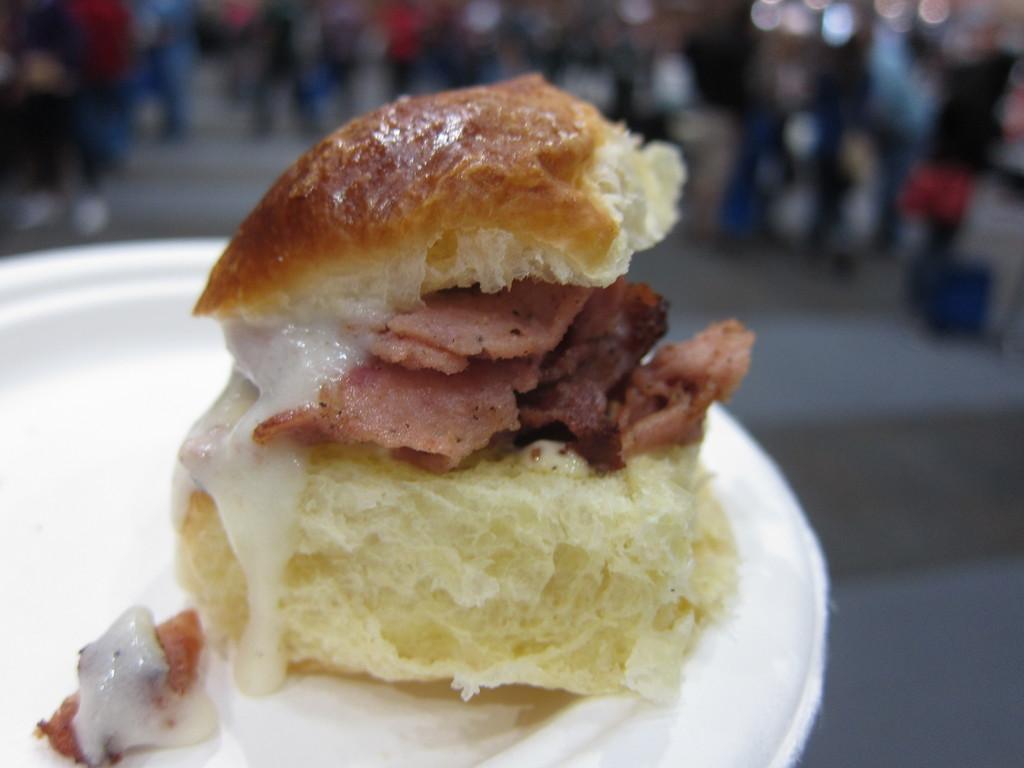How would you summarize this image in a sentence or two? In the foreground of this picture, there is a sandwich and a cream on it is placed on a white platter. In the background, there are persons blurred. 